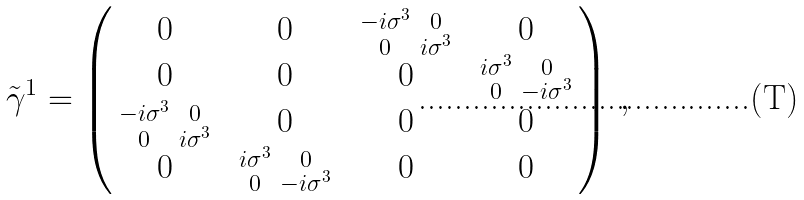Convert formula to latex. <formula><loc_0><loc_0><loc_500><loc_500>\, \tilde { \gamma } ^ { 1 } = \begin{pmatrix} 0 & 0 & \begin{smallmatrix} - i \sigma ^ { 3 } & 0 \\ 0 & i \sigma ^ { 3 } \end{smallmatrix} & 0 \\ 0 & 0 & 0 & \begin{smallmatrix} i \sigma ^ { 3 } & 0 \\ 0 & - i \sigma ^ { 3 } \end{smallmatrix} \\ \begin{smallmatrix} - i \sigma ^ { 3 } & 0 \\ 0 & i \sigma ^ { 3 } \end{smallmatrix} & 0 & 0 & 0 \\ 0 & \begin{smallmatrix} i \sigma ^ { 3 } & 0 \\ 0 & - i \sigma ^ { 3 } \end{smallmatrix} & 0 & 0 \end{pmatrix} \, , \\</formula> 